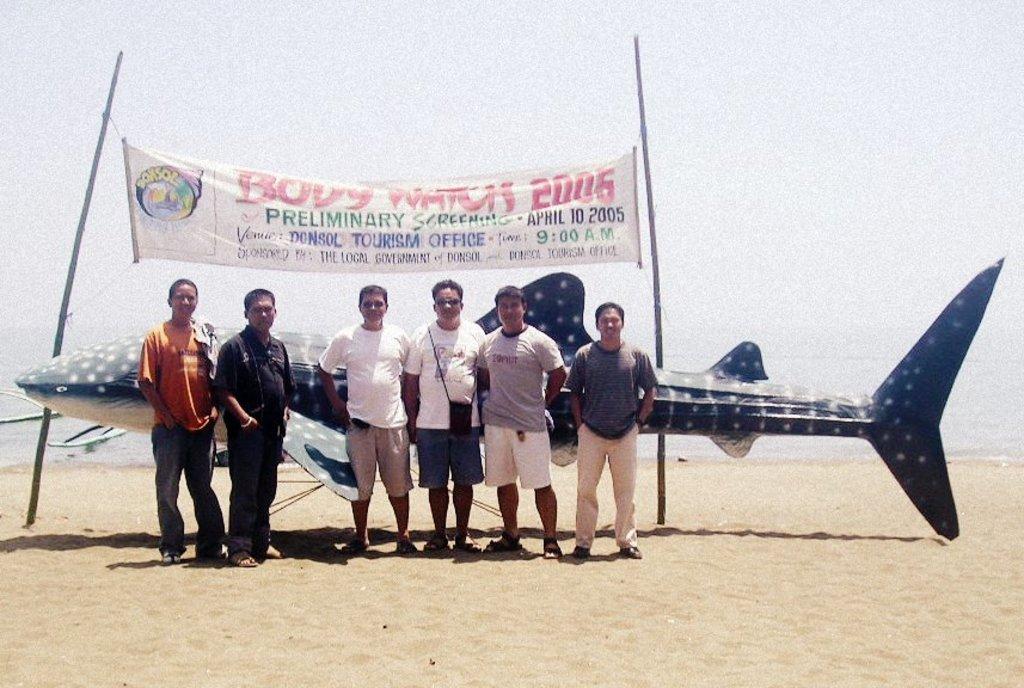What year is it?
Provide a succinct answer. 2005. 